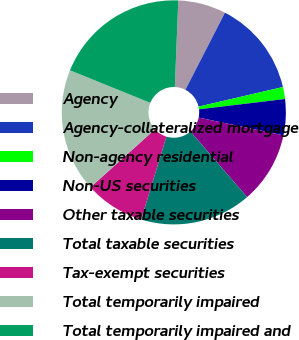<chart> <loc_0><loc_0><loc_500><loc_500><pie_chart><fcel>Agency<fcel>Agency-collateralized mortgage<fcel>Non-agency residential<fcel>Non-US securities<fcel>Other taxable securities<fcel>Total taxable securities<fcel>Tax-exempt securities<fcel>Total temporarily impaired<fcel>Total temporarily impaired and<nl><fcel>6.91%<fcel>13.82%<fcel>1.73%<fcel>5.19%<fcel>10.36%<fcel>16.06%<fcel>8.64%<fcel>17.78%<fcel>19.51%<nl></chart> 